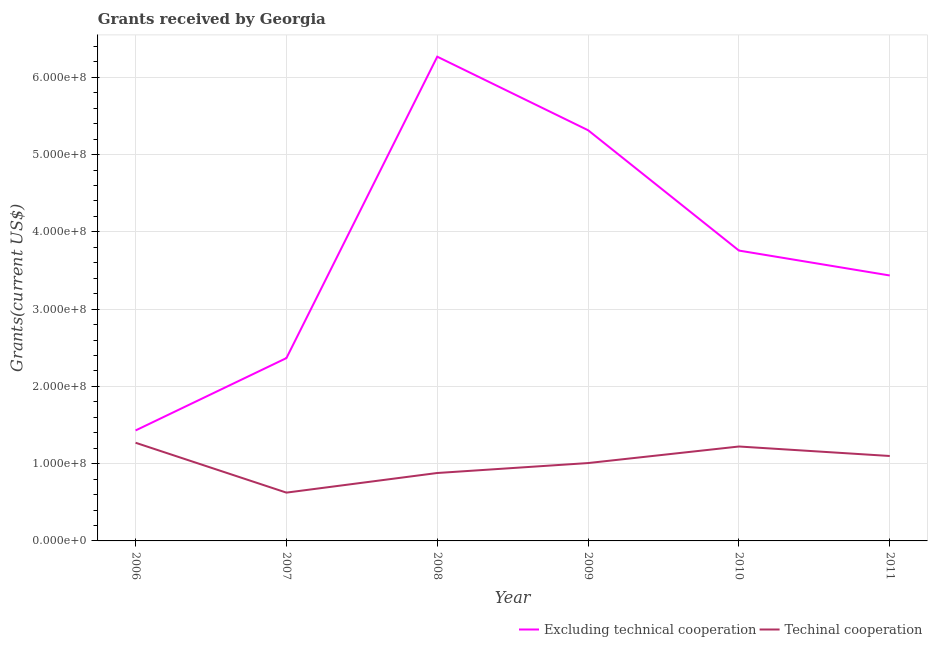What is the amount of grants received(including technical cooperation) in 2010?
Ensure brevity in your answer.  1.22e+08. Across all years, what is the maximum amount of grants received(excluding technical cooperation)?
Offer a very short reply. 6.27e+08. Across all years, what is the minimum amount of grants received(including technical cooperation)?
Your answer should be compact. 6.25e+07. In which year was the amount of grants received(excluding technical cooperation) minimum?
Keep it short and to the point. 2006. What is the total amount of grants received(including technical cooperation) in the graph?
Provide a short and direct response. 6.10e+08. What is the difference between the amount of grants received(including technical cooperation) in 2008 and that in 2011?
Ensure brevity in your answer.  -2.20e+07. What is the difference between the amount of grants received(including technical cooperation) in 2008 and the amount of grants received(excluding technical cooperation) in 2010?
Your response must be concise. -2.88e+08. What is the average amount of grants received(excluding technical cooperation) per year?
Offer a very short reply. 3.76e+08. In the year 2007, what is the difference between the amount of grants received(including technical cooperation) and amount of grants received(excluding technical cooperation)?
Your answer should be compact. -1.74e+08. What is the ratio of the amount of grants received(excluding technical cooperation) in 2006 to that in 2009?
Give a very brief answer. 0.27. Is the amount of grants received(excluding technical cooperation) in 2007 less than that in 2008?
Keep it short and to the point. Yes. What is the difference between the highest and the second highest amount of grants received(excluding technical cooperation)?
Provide a short and direct response. 9.52e+07. What is the difference between the highest and the lowest amount of grants received(excluding technical cooperation)?
Make the answer very short. 4.84e+08. In how many years, is the amount of grants received(excluding technical cooperation) greater than the average amount of grants received(excluding technical cooperation) taken over all years?
Provide a succinct answer. 2. Is the sum of the amount of grants received(excluding technical cooperation) in 2006 and 2010 greater than the maximum amount of grants received(including technical cooperation) across all years?
Your response must be concise. Yes. Does the amount of grants received(excluding technical cooperation) monotonically increase over the years?
Make the answer very short. No. Is the amount of grants received(excluding technical cooperation) strictly less than the amount of grants received(including technical cooperation) over the years?
Your response must be concise. No. How many lines are there?
Provide a short and direct response. 2. Are the values on the major ticks of Y-axis written in scientific E-notation?
Keep it short and to the point. Yes. Does the graph contain any zero values?
Provide a short and direct response. No. Does the graph contain grids?
Offer a terse response. Yes. How are the legend labels stacked?
Your answer should be compact. Horizontal. What is the title of the graph?
Ensure brevity in your answer.  Grants received by Georgia. What is the label or title of the Y-axis?
Make the answer very short. Grants(current US$). What is the Grants(current US$) in Excluding technical cooperation in 2006?
Offer a very short reply. 1.43e+08. What is the Grants(current US$) in Techinal cooperation in 2006?
Make the answer very short. 1.27e+08. What is the Grants(current US$) of Excluding technical cooperation in 2007?
Provide a succinct answer. 2.37e+08. What is the Grants(current US$) in Techinal cooperation in 2007?
Ensure brevity in your answer.  6.25e+07. What is the Grants(current US$) in Excluding technical cooperation in 2008?
Give a very brief answer. 6.27e+08. What is the Grants(current US$) of Techinal cooperation in 2008?
Offer a terse response. 8.79e+07. What is the Grants(current US$) in Excluding technical cooperation in 2009?
Your answer should be compact. 5.32e+08. What is the Grants(current US$) of Techinal cooperation in 2009?
Offer a terse response. 1.01e+08. What is the Grants(current US$) in Excluding technical cooperation in 2010?
Give a very brief answer. 3.76e+08. What is the Grants(current US$) of Techinal cooperation in 2010?
Provide a short and direct response. 1.22e+08. What is the Grants(current US$) in Excluding technical cooperation in 2011?
Keep it short and to the point. 3.44e+08. What is the Grants(current US$) in Techinal cooperation in 2011?
Provide a short and direct response. 1.10e+08. Across all years, what is the maximum Grants(current US$) in Excluding technical cooperation?
Make the answer very short. 6.27e+08. Across all years, what is the maximum Grants(current US$) of Techinal cooperation?
Your answer should be very brief. 1.27e+08. Across all years, what is the minimum Grants(current US$) in Excluding technical cooperation?
Your response must be concise. 1.43e+08. Across all years, what is the minimum Grants(current US$) in Techinal cooperation?
Offer a very short reply. 6.25e+07. What is the total Grants(current US$) in Excluding technical cooperation in the graph?
Offer a very short reply. 2.26e+09. What is the total Grants(current US$) of Techinal cooperation in the graph?
Keep it short and to the point. 6.10e+08. What is the difference between the Grants(current US$) of Excluding technical cooperation in 2006 and that in 2007?
Provide a succinct answer. -9.36e+07. What is the difference between the Grants(current US$) of Techinal cooperation in 2006 and that in 2007?
Keep it short and to the point. 6.46e+07. What is the difference between the Grants(current US$) in Excluding technical cooperation in 2006 and that in 2008?
Offer a terse response. -4.84e+08. What is the difference between the Grants(current US$) in Techinal cooperation in 2006 and that in 2008?
Your answer should be very brief. 3.92e+07. What is the difference between the Grants(current US$) in Excluding technical cooperation in 2006 and that in 2009?
Provide a short and direct response. -3.89e+08. What is the difference between the Grants(current US$) of Techinal cooperation in 2006 and that in 2009?
Your answer should be compact. 2.63e+07. What is the difference between the Grants(current US$) in Excluding technical cooperation in 2006 and that in 2010?
Your response must be concise. -2.33e+08. What is the difference between the Grants(current US$) in Techinal cooperation in 2006 and that in 2010?
Make the answer very short. 4.86e+06. What is the difference between the Grants(current US$) in Excluding technical cooperation in 2006 and that in 2011?
Provide a short and direct response. -2.01e+08. What is the difference between the Grants(current US$) in Techinal cooperation in 2006 and that in 2011?
Your answer should be compact. 1.71e+07. What is the difference between the Grants(current US$) of Excluding technical cooperation in 2007 and that in 2008?
Ensure brevity in your answer.  -3.90e+08. What is the difference between the Grants(current US$) of Techinal cooperation in 2007 and that in 2008?
Offer a terse response. -2.54e+07. What is the difference between the Grants(current US$) of Excluding technical cooperation in 2007 and that in 2009?
Your answer should be very brief. -2.95e+08. What is the difference between the Grants(current US$) of Techinal cooperation in 2007 and that in 2009?
Your answer should be compact. -3.83e+07. What is the difference between the Grants(current US$) in Excluding technical cooperation in 2007 and that in 2010?
Provide a short and direct response. -1.39e+08. What is the difference between the Grants(current US$) of Techinal cooperation in 2007 and that in 2010?
Give a very brief answer. -5.97e+07. What is the difference between the Grants(current US$) of Excluding technical cooperation in 2007 and that in 2011?
Ensure brevity in your answer.  -1.07e+08. What is the difference between the Grants(current US$) of Techinal cooperation in 2007 and that in 2011?
Offer a terse response. -4.74e+07. What is the difference between the Grants(current US$) of Excluding technical cooperation in 2008 and that in 2009?
Provide a succinct answer. 9.52e+07. What is the difference between the Grants(current US$) in Techinal cooperation in 2008 and that in 2009?
Give a very brief answer. -1.29e+07. What is the difference between the Grants(current US$) in Excluding technical cooperation in 2008 and that in 2010?
Provide a succinct answer. 2.51e+08. What is the difference between the Grants(current US$) in Techinal cooperation in 2008 and that in 2010?
Give a very brief answer. -3.43e+07. What is the difference between the Grants(current US$) of Excluding technical cooperation in 2008 and that in 2011?
Give a very brief answer. 2.83e+08. What is the difference between the Grants(current US$) in Techinal cooperation in 2008 and that in 2011?
Offer a terse response. -2.20e+07. What is the difference between the Grants(current US$) in Excluding technical cooperation in 2009 and that in 2010?
Give a very brief answer. 1.56e+08. What is the difference between the Grants(current US$) of Techinal cooperation in 2009 and that in 2010?
Your answer should be compact. -2.14e+07. What is the difference between the Grants(current US$) in Excluding technical cooperation in 2009 and that in 2011?
Offer a terse response. 1.88e+08. What is the difference between the Grants(current US$) in Techinal cooperation in 2009 and that in 2011?
Ensure brevity in your answer.  -9.14e+06. What is the difference between the Grants(current US$) in Excluding technical cooperation in 2010 and that in 2011?
Keep it short and to the point. 3.22e+07. What is the difference between the Grants(current US$) in Techinal cooperation in 2010 and that in 2011?
Offer a very short reply. 1.23e+07. What is the difference between the Grants(current US$) of Excluding technical cooperation in 2006 and the Grants(current US$) of Techinal cooperation in 2007?
Make the answer very short. 8.05e+07. What is the difference between the Grants(current US$) of Excluding technical cooperation in 2006 and the Grants(current US$) of Techinal cooperation in 2008?
Ensure brevity in your answer.  5.51e+07. What is the difference between the Grants(current US$) in Excluding technical cooperation in 2006 and the Grants(current US$) in Techinal cooperation in 2009?
Offer a very short reply. 4.22e+07. What is the difference between the Grants(current US$) of Excluding technical cooperation in 2006 and the Grants(current US$) of Techinal cooperation in 2010?
Give a very brief answer. 2.08e+07. What is the difference between the Grants(current US$) of Excluding technical cooperation in 2006 and the Grants(current US$) of Techinal cooperation in 2011?
Provide a short and direct response. 3.31e+07. What is the difference between the Grants(current US$) of Excluding technical cooperation in 2007 and the Grants(current US$) of Techinal cooperation in 2008?
Provide a succinct answer. 1.49e+08. What is the difference between the Grants(current US$) of Excluding technical cooperation in 2007 and the Grants(current US$) of Techinal cooperation in 2009?
Your answer should be compact. 1.36e+08. What is the difference between the Grants(current US$) of Excluding technical cooperation in 2007 and the Grants(current US$) of Techinal cooperation in 2010?
Your answer should be compact. 1.14e+08. What is the difference between the Grants(current US$) in Excluding technical cooperation in 2007 and the Grants(current US$) in Techinal cooperation in 2011?
Ensure brevity in your answer.  1.27e+08. What is the difference between the Grants(current US$) of Excluding technical cooperation in 2008 and the Grants(current US$) of Techinal cooperation in 2009?
Make the answer very short. 5.26e+08. What is the difference between the Grants(current US$) of Excluding technical cooperation in 2008 and the Grants(current US$) of Techinal cooperation in 2010?
Your answer should be very brief. 5.05e+08. What is the difference between the Grants(current US$) in Excluding technical cooperation in 2008 and the Grants(current US$) in Techinal cooperation in 2011?
Offer a terse response. 5.17e+08. What is the difference between the Grants(current US$) of Excluding technical cooperation in 2009 and the Grants(current US$) of Techinal cooperation in 2010?
Offer a very short reply. 4.09e+08. What is the difference between the Grants(current US$) of Excluding technical cooperation in 2009 and the Grants(current US$) of Techinal cooperation in 2011?
Offer a very short reply. 4.22e+08. What is the difference between the Grants(current US$) in Excluding technical cooperation in 2010 and the Grants(current US$) in Techinal cooperation in 2011?
Your answer should be compact. 2.66e+08. What is the average Grants(current US$) of Excluding technical cooperation per year?
Ensure brevity in your answer.  3.76e+08. What is the average Grants(current US$) of Techinal cooperation per year?
Your answer should be very brief. 1.02e+08. In the year 2006, what is the difference between the Grants(current US$) in Excluding technical cooperation and Grants(current US$) in Techinal cooperation?
Keep it short and to the point. 1.59e+07. In the year 2007, what is the difference between the Grants(current US$) in Excluding technical cooperation and Grants(current US$) in Techinal cooperation?
Give a very brief answer. 1.74e+08. In the year 2008, what is the difference between the Grants(current US$) of Excluding technical cooperation and Grants(current US$) of Techinal cooperation?
Ensure brevity in your answer.  5.39e+08. In the year 2009, what is the difference between the Grants(current US$) in Excluding technical cooperation and Grants(current US$) in Techinal cooperation?
Provide a succinct answer. 4.31e+08. In the year 2010, what is the difference between the Grants(current US$) of Excluding technical cooperation and Grants(current US$) of Techinal cooperation?
Provide a succinct answer. 2.54e+08. In the year 2011, what is the difference between the Grants(current US$) of Excluding technical cooperation and Grants(current US$) of Techinal cooperation?
Make the answer very short. 2.34e+08. What is the ratio of the Grants(current US$) of Excluding technical cooperation in 2006 to that in 2007?
Ensure brevity in your answer.  0.6. What is the ratio of the Grants(current US$) in Techinal cooperation in 2006 to that in 2007?
Your answer should be very brief. 2.03. What is the ratio of the Grants(current US$) in Excluding technical cooperation in 2006 to that in 2008?
Provide a succinct answer. 0.23. What is the ratio of the Grants(current US$) of Techinal cooperation in 2006 to that in 2008?
Give a very brief answer. 1.45. What is the ratio of the Grants(current US$) in Excluding technical cooperation in 2006 to that in 2009?
Your response must be concise. 0.27. What is the ratio of the Grants(current US$) of Techinal cooperation in 2006 to that in 2009?
Your answer should be very brief. 1.26. What is the ratio of the Grants(current US$) in Excluding technical cooperation in 2006 to that in 2010?
Offer a very short reply. 0.38. What is the ratio of the Grants(current US$) of Techinal cooperation in 2006 to that in 2010?
Offer a terse response. 1.04. What is the ratio of the Grants(current US$) in Excluding technical cooperation in 2006 to that in 2011?
Give a very brief answer. 0.42. What is the ratio of the Grants(current US$) in Techinal cooperation in 2006 to that in 2011?
Offer a very short reply. 1.16. What is the ratio of the Grants(current US$) of Excluding technical cooperation in 2007 to that in 2008?
Your answer should be compact. 0.38. What is the ratio of the Grants(current US$) of Techinal cooperation in 2007 to that in 2008?
Make the answer very short. 0.71. What is the ratio of the Grants(current US$) in Excluding technical cooperation in 2007 to that in 2009?
Give a very brief answer. 0.45. What is the ratio of the Grants(current US$) in Techinal cooperation in 2007 to that in 2009?
Provide a succinct answer. 0.62. What is the ratio of the Grants(current US$) in Excluding technical cooperation in 2007 to that in 2010?
Provide a short and direct response. 0.63. What is the ratio of the Grants(current US$) in Techinal cooperation in 2007 to that in 2010?
Give a very brief answer. 0.51. What is the ratio of the Grants(current US$) in Excluding technical cooperation in 2007 to that in 2011?
Your answer should be very brief. 0.69. What is the ratio of the Grants(current US$) of Techinal cooperation in 2007 to that in 2011?
Provide a succinct answer. 0.57. What is the ratio of the Grants(current US$) of Excluding technical cooperation in 2008 to that in 2009?
Make the answer very short. 1.18. What is the ratio of the Grants(current US$) in Techinal cooperation in 2008 to that in 2009?
Provide a succinct answer. 0.87. What is the ratio of the Grants(current US$) of Excluding technical cooperation in 2008 to that in 2010?
Make the answer very short. 1.67. What is the ratio of the Grants(current US$) in Techinal cooperation in 2008 to that in 2010?
Your response must be concise. 0.72. What is the ratio of the Grants(current US$) in Excluding technical cooperation in 2008 to that in 2011?
Your answer should be compact. 1.82. What is the ratio of the Grants(current US$) of Techinal cooperation in 2008 to that in 2011?
Ensure brevity in your answer.  0.8. What is the ratio of the Grants(current US$) of Excluding technical cooperation in 2009 to that in 2010?
Make the answer very short. 1.41. What is the ratio of the Grants(current US$) in Techinal cooperation in 2009 to that in 2010?
Provide a short and direct response. 0.82. What is the ratio of the Grants(current US$) in Excluding technical cooperation in 2009 to that in 2011?
Your answer should be compact. 1.55. What is the ratio of the Grants(current US$) in Techinal cooperation in 2009 to that in 2011?
Give a very brief answer. 0.92. What is the ratio of the Grants(current US$) in Excluding technical cooperation in 2010 to that in 2011?
Keep it short and to the point. 1.09. What is the ratio of the Grants(current US$) of Techinal cooperation in 2010 to that in 2011?
Make the answer very short. 1.11. What is the difference between the highest and the second highest Grants(current US$) of Excluding technical cooperation?
Your response must be concise. 9.52e+07. What is the difference between the highest and the second highest Grants(current US$) in Techinal cooperation?
Offer a terse response. 4.86e+06. What is the difference between the highest and the lowest Grants(current US$) of Excluding technical cooperation?
Make the answer very short. 4.84e+08. What is the difference between the highest and the lowest Grants(current US$) of Techinal cooperation?
Provide a short and direct response. 6.46e+07. 